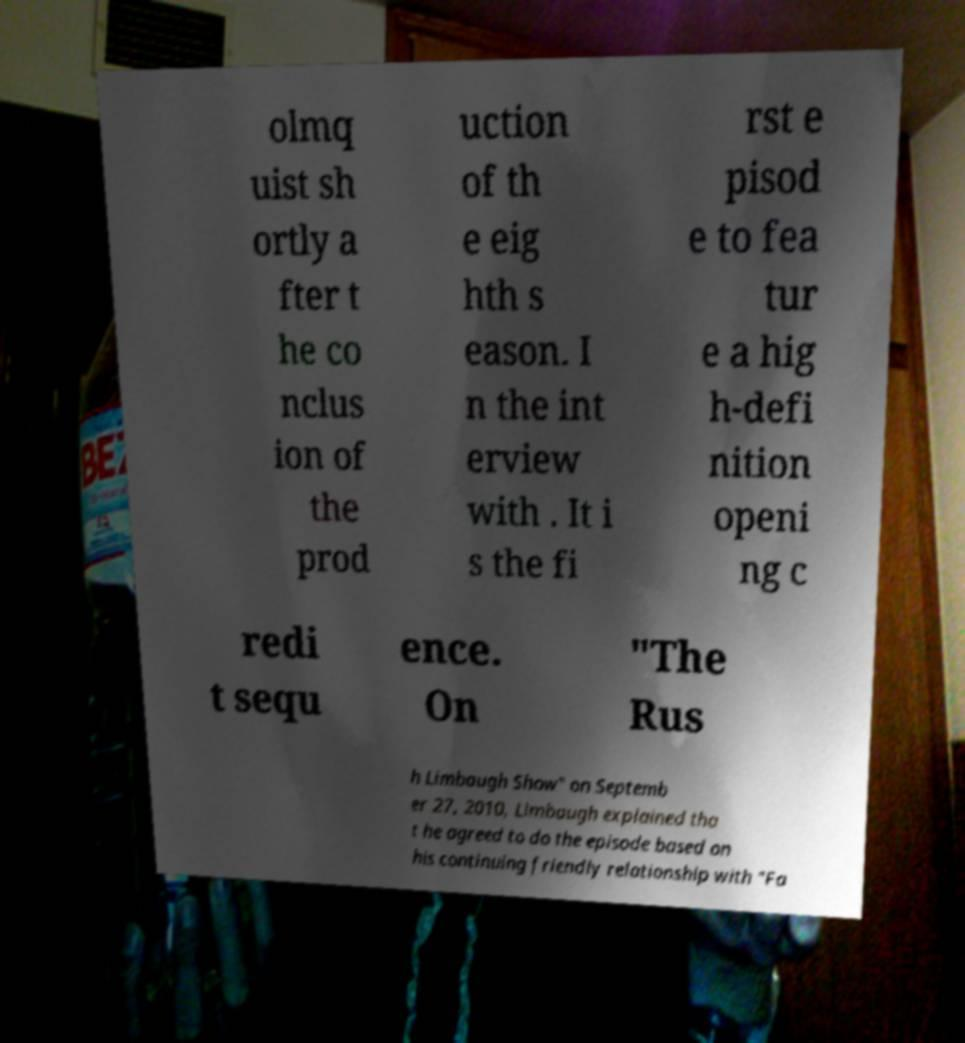There's text embedded in this image that I need extracted. Can you transcribe it verbatim? olmq uist sh ortly a fter t he co nclus ion of the prod uction of th e eig hth s eason. I n the int erview with . It i s the fi rst e pisod e to fea tur e a hig h-defi nition openi ng c redi t sequ ence. On "The Rus h Limbaugh Show" on Septemb er 27, 2010, Limbaugh explained tha t he agreed to do the episode based on his continuing friendly relationship with "Fa 